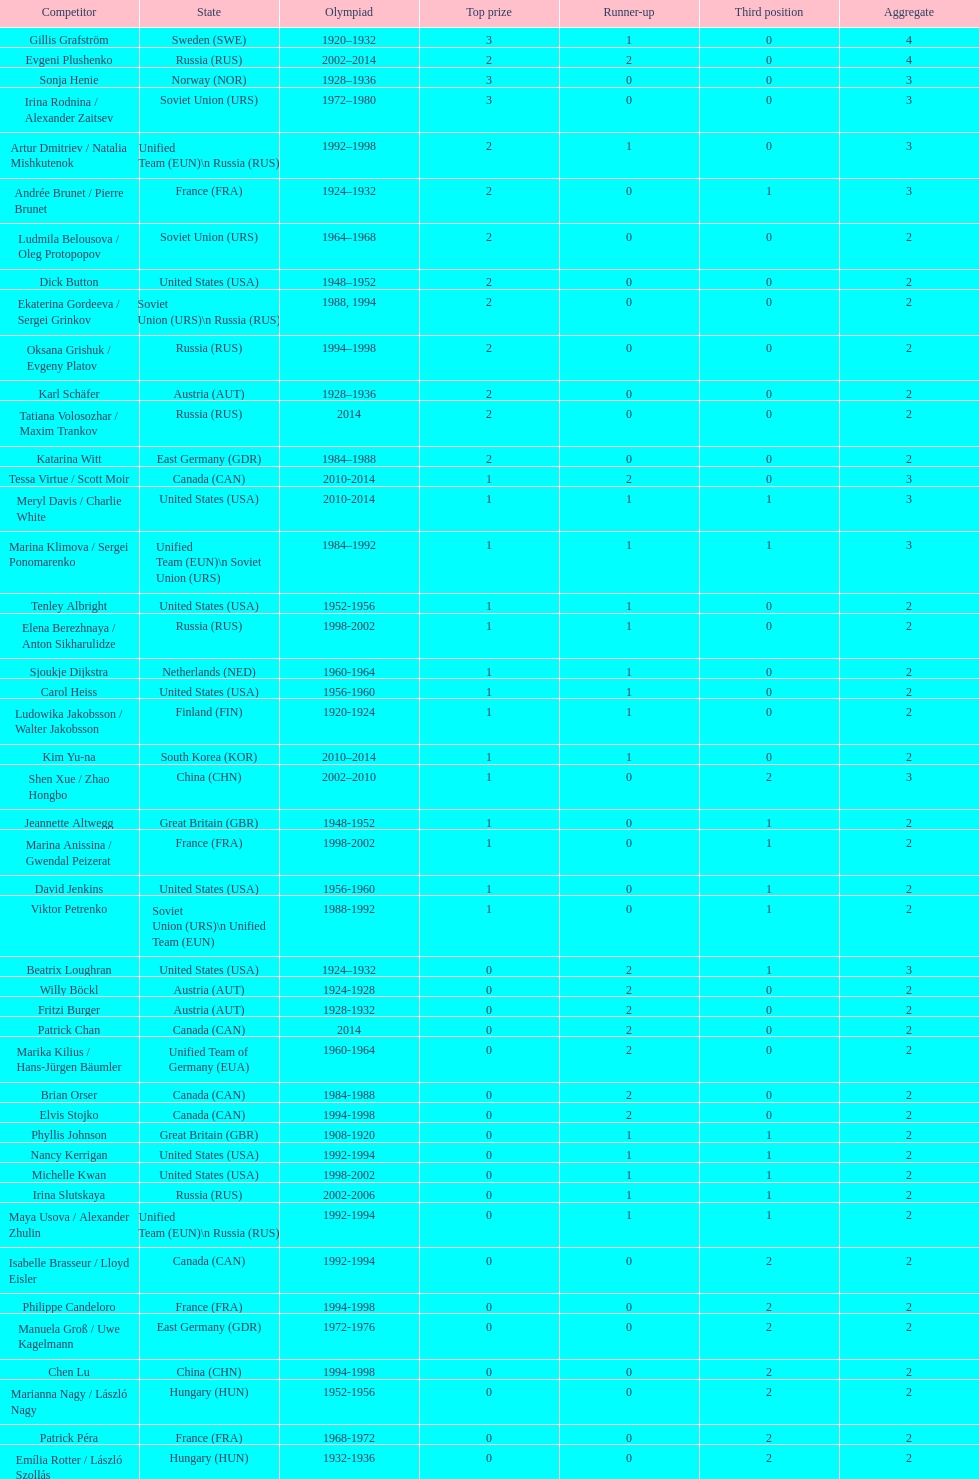How many total medals has the united states won in women's figure skating? 16. 